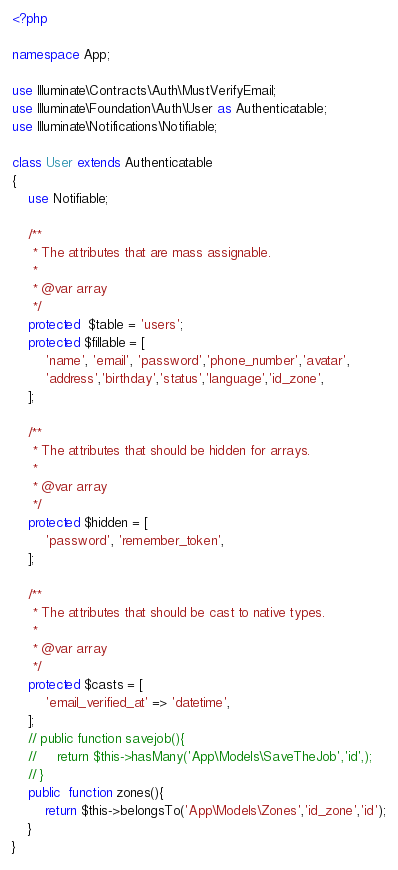<code> <loc_0><loc_0><loc_500><loc_500><_PHP_><?php

namespace App;

use Illuminate\Contracts\Auth\MustVerifyEmail;
use Illuminate\Foundation\Auth\User as Authenticatable;
use Illuminate\Notifications\Notifiable;

class User extends Authenticatable
{
    use Notifiable;

    /**
     * The attributes that are mass assignable.
     *
     * @var array
     */
    protected  $table = 'users';
    protected $fillable = [
        'name', 'email', 'password','phone_number','avatar',
        'address','birthday','status','language','id_zone',
    ];

    /**
     * The attributes that should be hidden for arrays.
     *
     * @var array
     */
    protected $hidden = [
        'password', 'remember_token',
    ];

    /**
     * The attributes that should be cast to native types.
     *
     * @var array
     */
    protected $casts = [
        'email_verified_at' => 'datetime',
    ];
    // public function savejob(){
    //     return $this->hasMany('App\Models\SaveTheJob','id',);
    // }
    public  function zones(){
        return $this->belongsTo('App\Models\Zones','id_zone','id');
    }
}</code> 